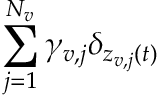<formula> <loc_0><loc_0><loc_500><loc_500>\sum _ { j = 1 } ^ { N _ { v } } \gamma _ { v , j } \delta _ { z _ { v , j } ( t ) }</formula> 